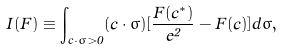Convert formula to latex. <formula><loc_0><loc_0><loc_500><loc_500>I ( F ) \equiv \int _ { { c } \cdot { \hat { \sigma } } > 0 } ( { c } \cdot { \hat { \sigma } } ) [ \frac { F ( { c } ^ { * } ) } { e ^ { 2 } } - F ( { c } ) ] d { \hat { \sigma } } ,</formula> 